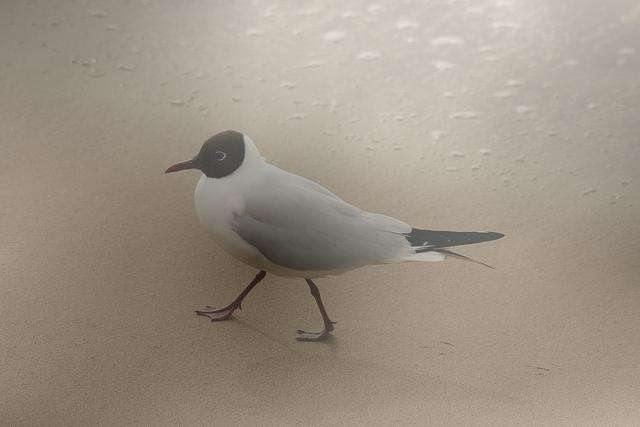Can you describe the bird in this image? Certainly! The bird appears to be a seagull, characterized by its white plumage with gray back and wings, a distinctive black headcap, and a thin, pointed beak. It stands on sandy ground, likely a beach, with raindrops subtly imprinted on the sand around it. 